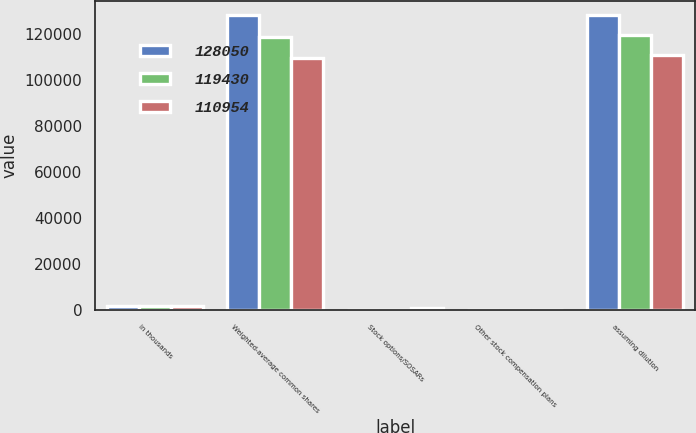Convert chart to OTSL. <chart><loc_0><loc_0><loc_500><loc_500><stacked_bar_chart><ecel><fcel>in thousands<fcel>Weighted-average common shares<fcel>Stock options/SOSARs<fcel>Other stock compensation plans<fcel>assuming dilution<nl><fcel>128050<fcel>2010<fcel>128050<fcel>0<fcel>0<fcel>128050<nl><fcel>119430<fcel>2009<fcel>118891<fcel>269<fcel>270<fcel>119430<nl><fcel>110954<fcel>2008<fcel>109774<fcel>905<fcel>275<fcel>110954<nl></chart> 